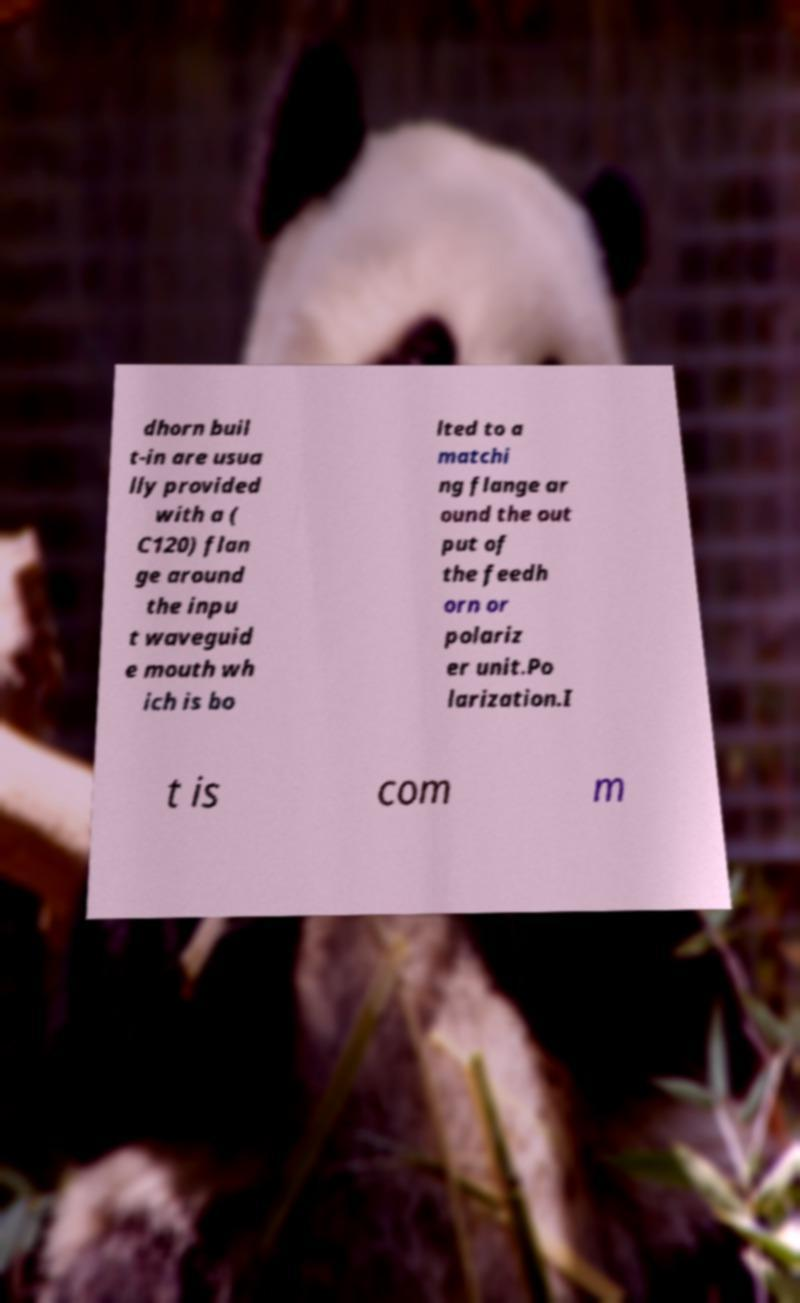Can you read and provide the text displayed in the image?This photo seems to have some interesting text. Can you extract and type it out for me? dhorn buil t-in are usua lly provided with a ( C120) flan ge around the inpu t waveguid e mouth wh ich is bo lted to a matchi ng flange ar ound the out put of the feedh orn or polariz er unit.Po larization.I t is com m 